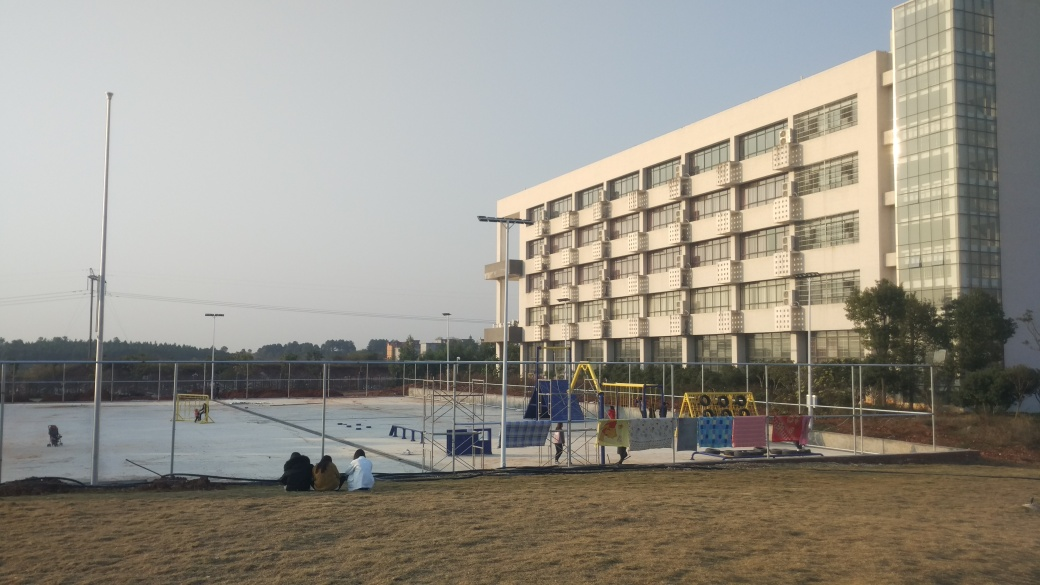Does this image suggest anything about the time of day? Yes, the long shadows cast on the ground and the warm, soft quality of the light suggest that this photo was taken either in the early morning or late afternoon, typically known as the 'golden hours' for photography due to the favorable lighting conditions. 